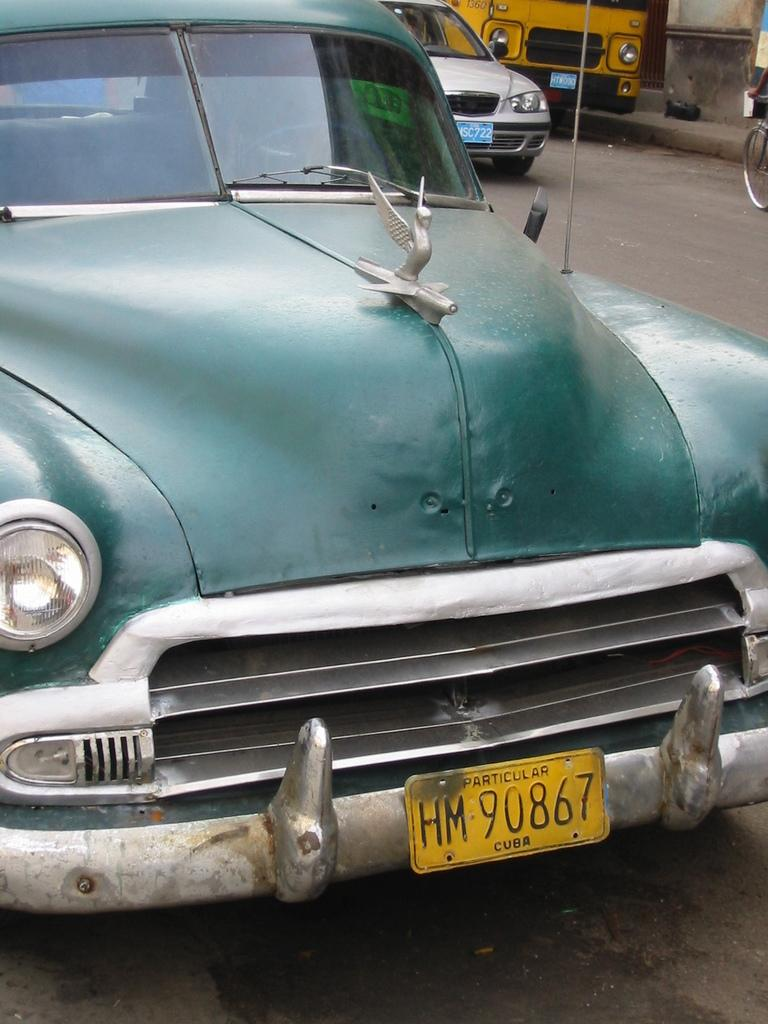<image>
Create a compact narrative representing the image presented. A battered old automobile sports a bent yellow Cuba license plate. 